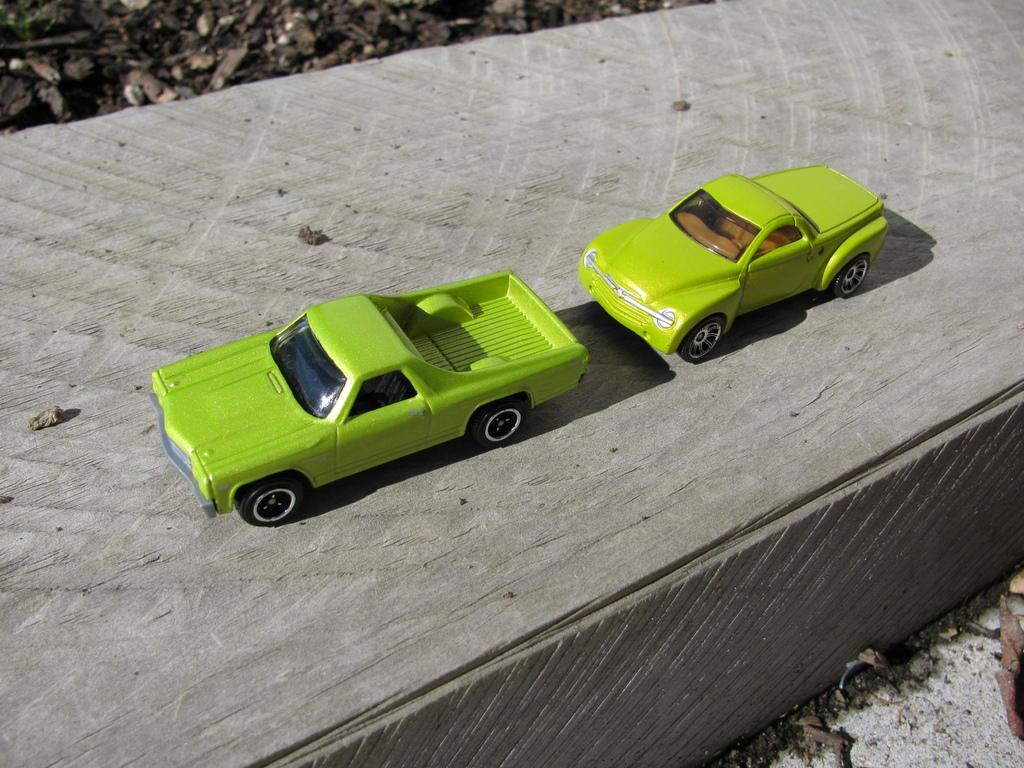What objects are present in the image? There are two toy cars in the image. Where are the toy cars located? The toy cars are on a road. What color are the toy cars? The toy cars are green in color. What type of treatment is being administered to the toy cars in the image? There is no treatment being administered to the toy cars in the image; they are simply sitting on a road. 